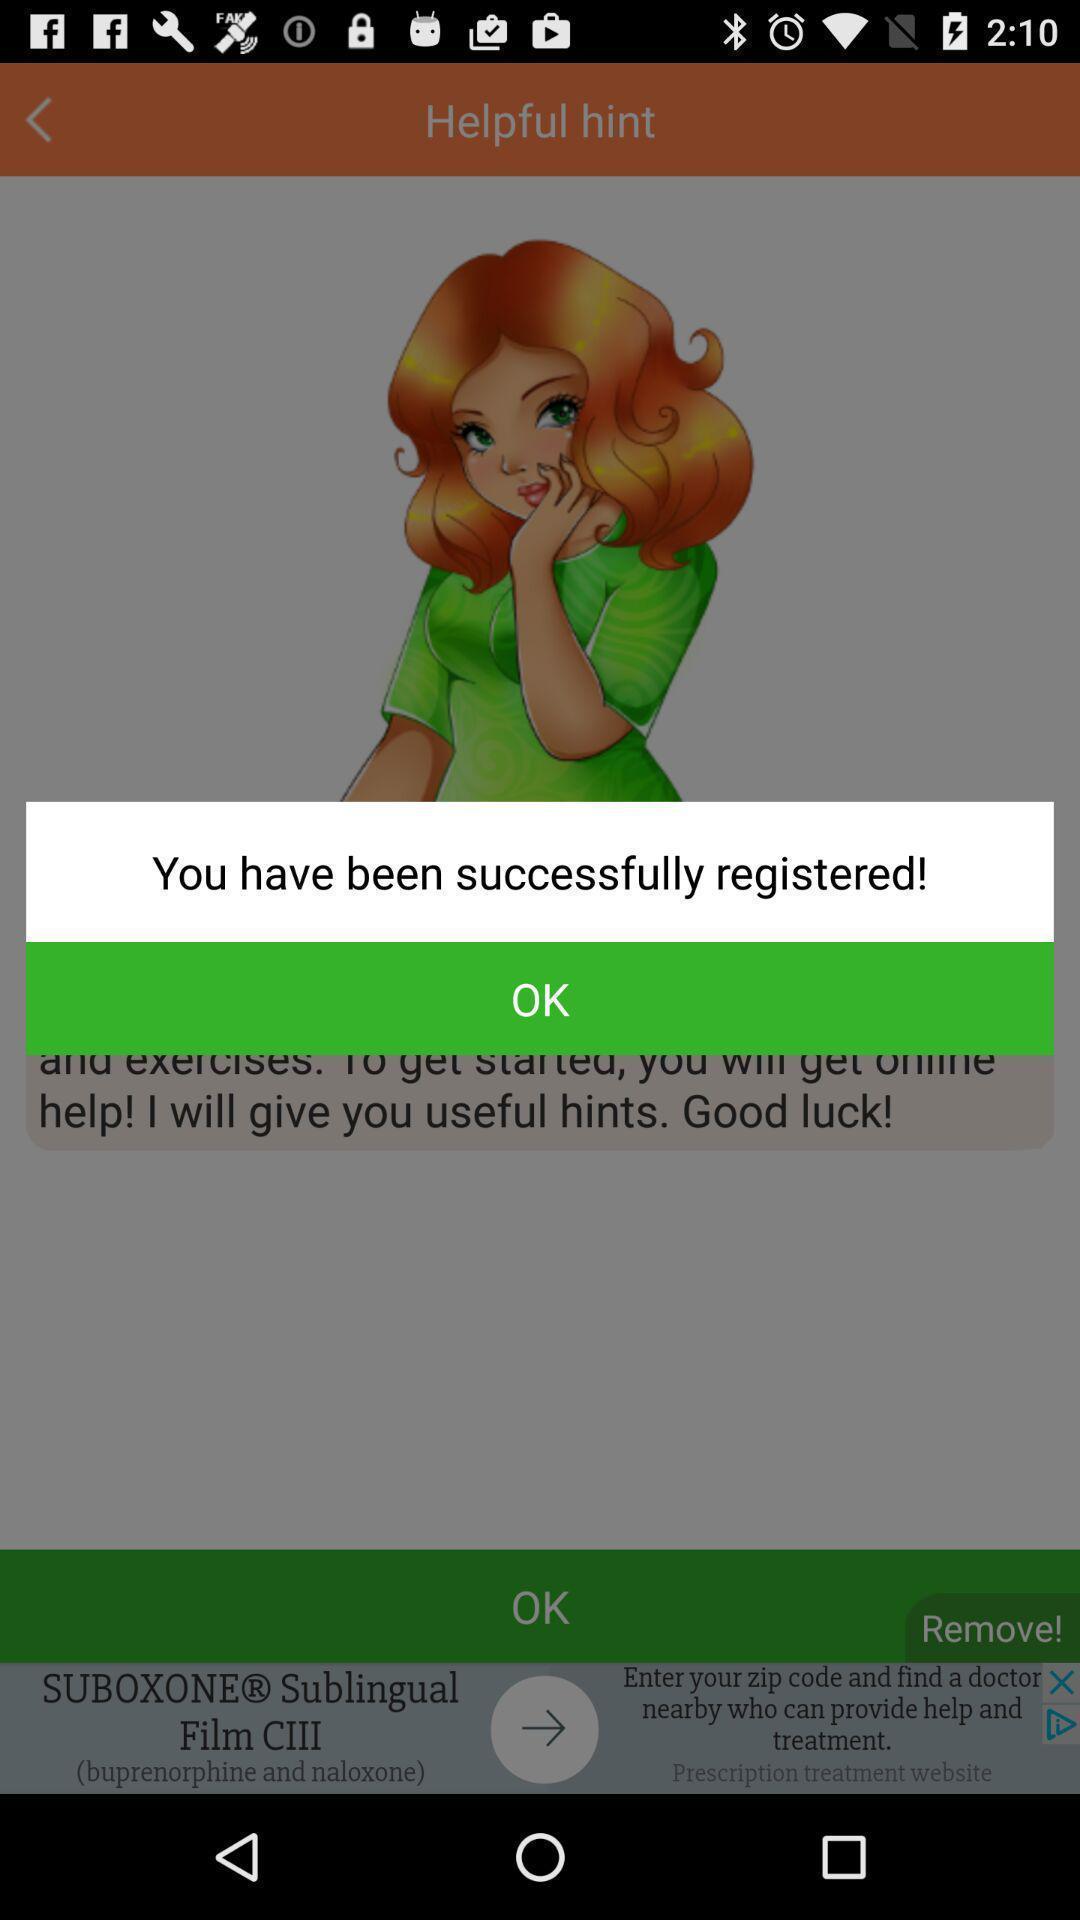What details can you identify in this image? Pop-up showing alert message. 